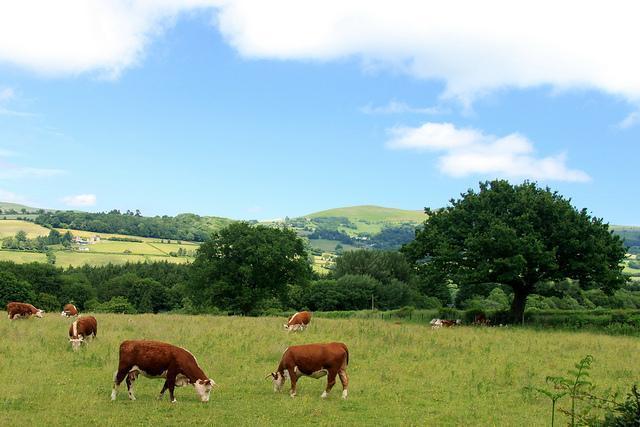How many cows appear to be eating?
Give a very brief answer. 6. How many cows are there?
Give a very brief answer. 2. 